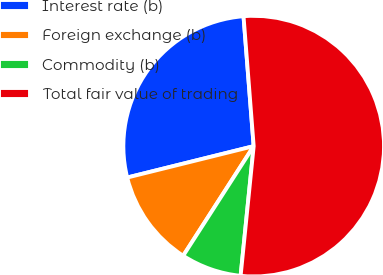<chart> <loc_0><loc_0><loc_500><loc_500><pie_chart><fcel>Interest rate (b)<fcel>Foreign exchange (b)<fcel>Commodity (b)<fcel>Total fair value of trading<nl><fcel>27.63%<fcel>12.03%<fcel>7.5%<fcel>52.84%<nl></chart> 